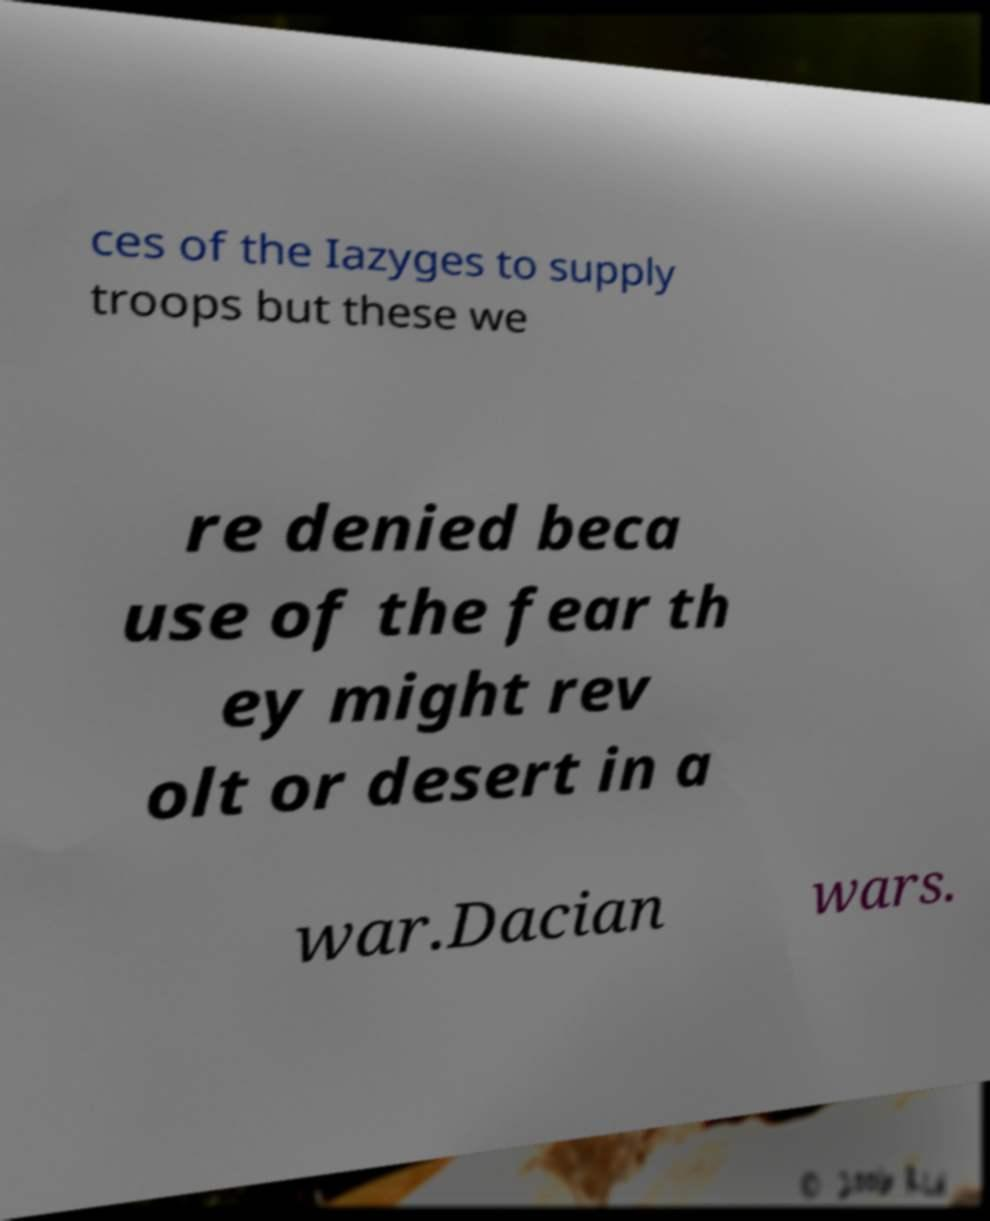Please read and relay the text visible in this image. What does it say? ces of the Iazyges to supply troops but these we re denied beca use of the fear th ey might rev olt or desert in a war.Dacian wars. 